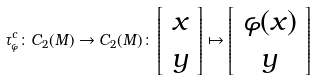<formula> <loc_0><loc_0><loc_500><loc_500>\tau _ { \varphi } ^ { c } \colon C _ { 2 } ( M ) \rightarrow C _ { 2 } ( M ) \colon \left [ \begin{array} { l } x \\ y \end{array} \right ] \mapsto \left [ \begin{array} { c } \varphi ( x ) \\ y \end{array} \right ]</formula> 